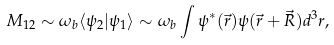<formula> <loc_0><loc_0><loc_500><loc_500>M _ { 1 2 } \sim \omega _ { b } \langle \psi _ { 2 } | \psi _ { 1 } \rangle \sim \omega _ { b } \int \psi ^ { * } ( \vec { r } ) \psi ( \vec { r } + \vec { R } ) d ^ { 3 } r ,</formula> 